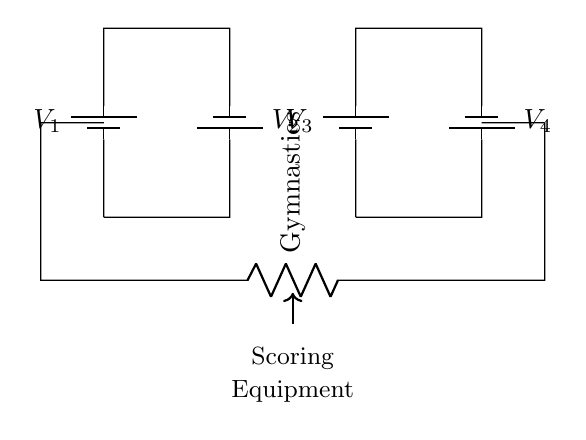What type of circuit is this? This circuit is a parallel circuit because the battery connections run alongside each other, allowing multiple paths for current.
Answer: Parallel How many batteries are used in this circuit? There are four batteries shown in the circuit diagram, which are all connected in parallel.
Answer: Four What is the role of the resistor in this circuit? The resistor, labeled as "Gymnastics," likely represents a load that the circuit is powering, which might be used for scoring equipment in gymnastics.
Answer: Load What is the voltage across the scoring equipment? In a parallel circuit, the voltage across the load is equal to the voltage of the individual battery, which is not specified, so it's considered the same as the connected batteries.
Answer: Equal to battery voltage Do the batteries provide the same or different voltages? The circuit diagram does not specify different voltages; thus, it is inferred that the connected batteries either provide the same voltage or the system is designed for a uniform voltage.
Answer: Same or uniform How does connecting batteries in parallel affect total voltage? In parallel, the total voltage remains the same as the voltage of one battery, while the total capacity (amp hours) increases. Therefore, more runtime is available.
Answer: Same as one battery voltage 